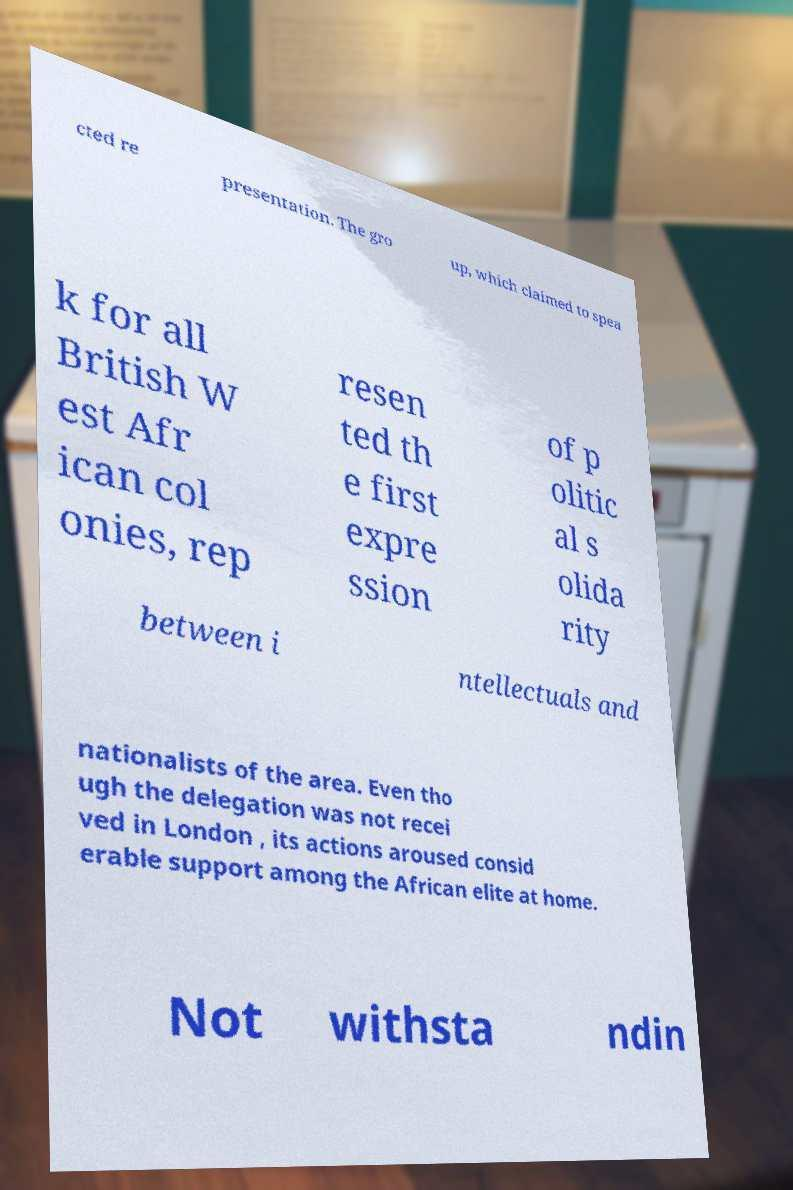For documentation purposes, I need the text within this image transcribed. Could you provide that? cted re presentation. The gro up, which claimed to spea k for all British W est Afr ican col onies, rep resen ted th e first expre ssion of p olitic al s olida rity between i ntellectuals and nationalists of the area. Even tho ugh the delegation was not recei ved in London , its actions aroused consid erable support among the African elite at home. Not withsta ndin 